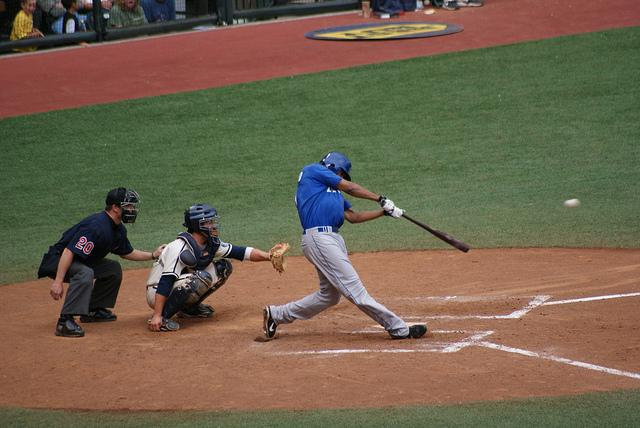What is the gear called that the umpire is wearing on his face?

Choices:
A) glasses
B) goggles
C) umpire mask
D) binoculars umpire mask 